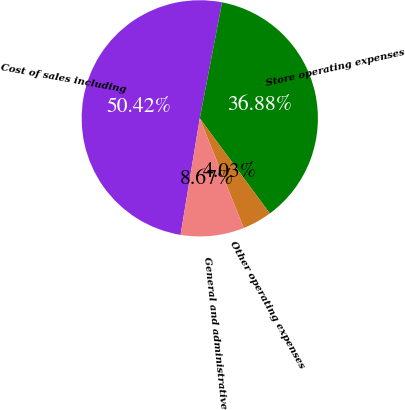<chart> <loc_0><loc_0><loc_500><loc_500><pie_chart><fcel>Cost of sales including<fcel>Store operating expenses<fcel>Other operating expenses<fcel>General and administrative<nl><fcel>50.42%<fcel>36.88%<fcel>4.03%<fcel>8.67%<nl></chart> 